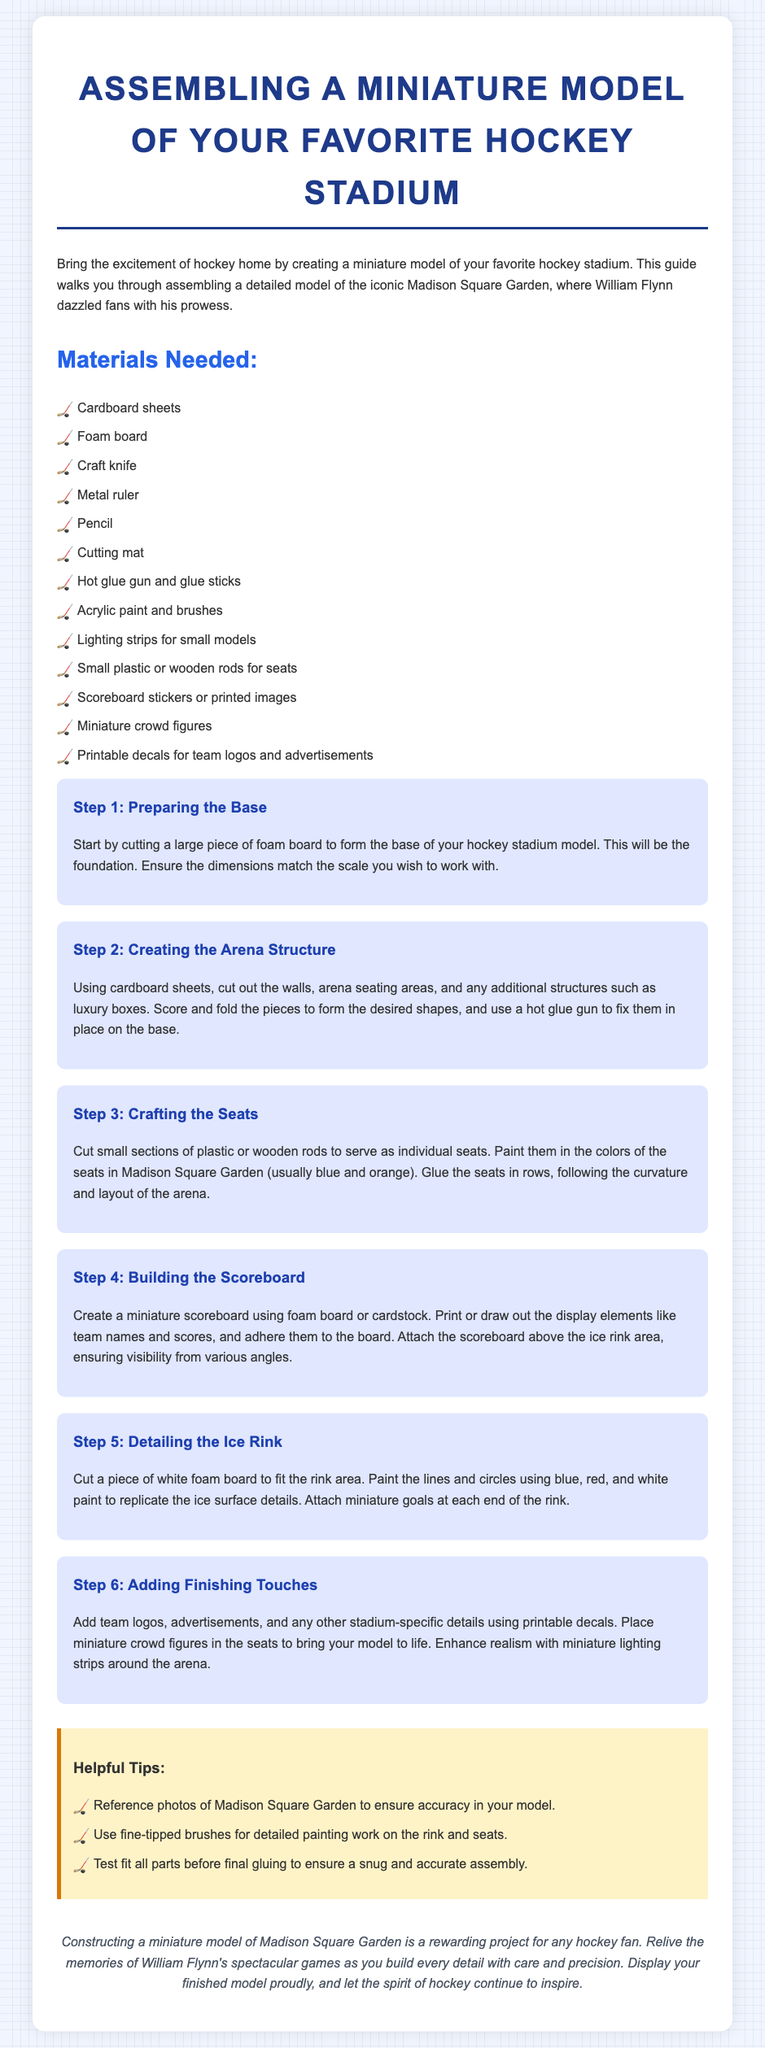What is the title of the document? The title is prominently displayed at the top of the document and is "Assembling a Miniature Model of Your Favorite Hockey Stadium."
Answer: Assembling a Miniature Model of Your Favorite Hockey Stadium What is the first material listed? The materials needed are presented in a bulleted list, with the first item being "Cardboard sheets."
Answer: Cardboard sheets How many steps are there in the assembly process? The document outlines a total of six distinct steps for assembling the model.
Answer: 6 What color is used for the seats in Madison Square Garden? The instructions specify to paint the seats in the colors of blue and orange.
Answer: Blue and orange What should you do before final gluing? The helpful tips section suggests to "Test fit all parts before final gluing."
Answer: Test fit all parts What does the conclusion state is the main benefit of constructing the model? The conclusion emphasizes that constructing the model is a "rewarding project for any hockey fan."
Answer: Rewarding project What kind of lighting is recommended for small models? The materials list mentions "Lighting strips for small models."
Answer: Lighting strips Which ice surface details should be painted? The step on detailing the ice rink indicates to paint the lines and circles using blue, red, and white paint.
Answer: Lines and circles What is the last step in the assembly instructions? The last step in the instructions is "Adding Finishing Touches."
Answer: Adding Finishing Touches 